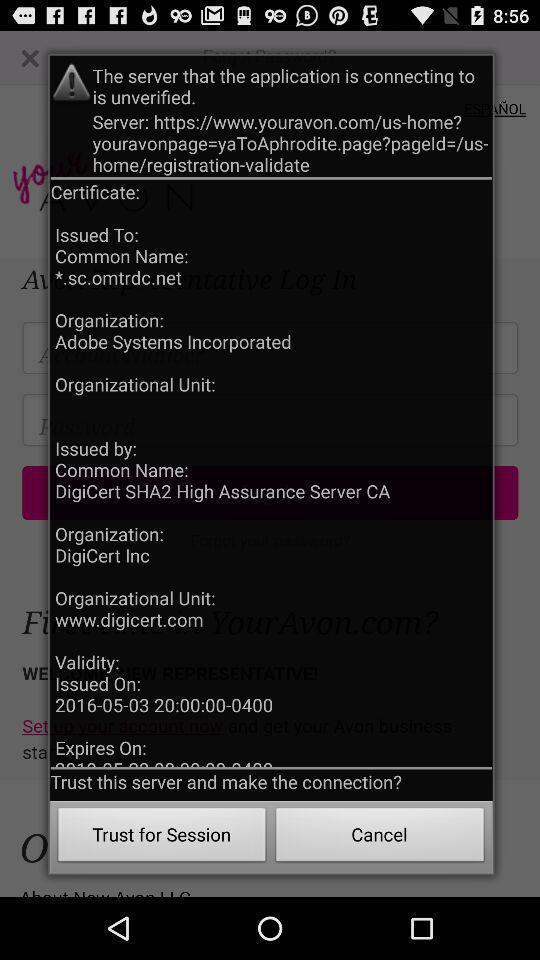Tell me what you see in this picture. Popup window showing details about server connection. 